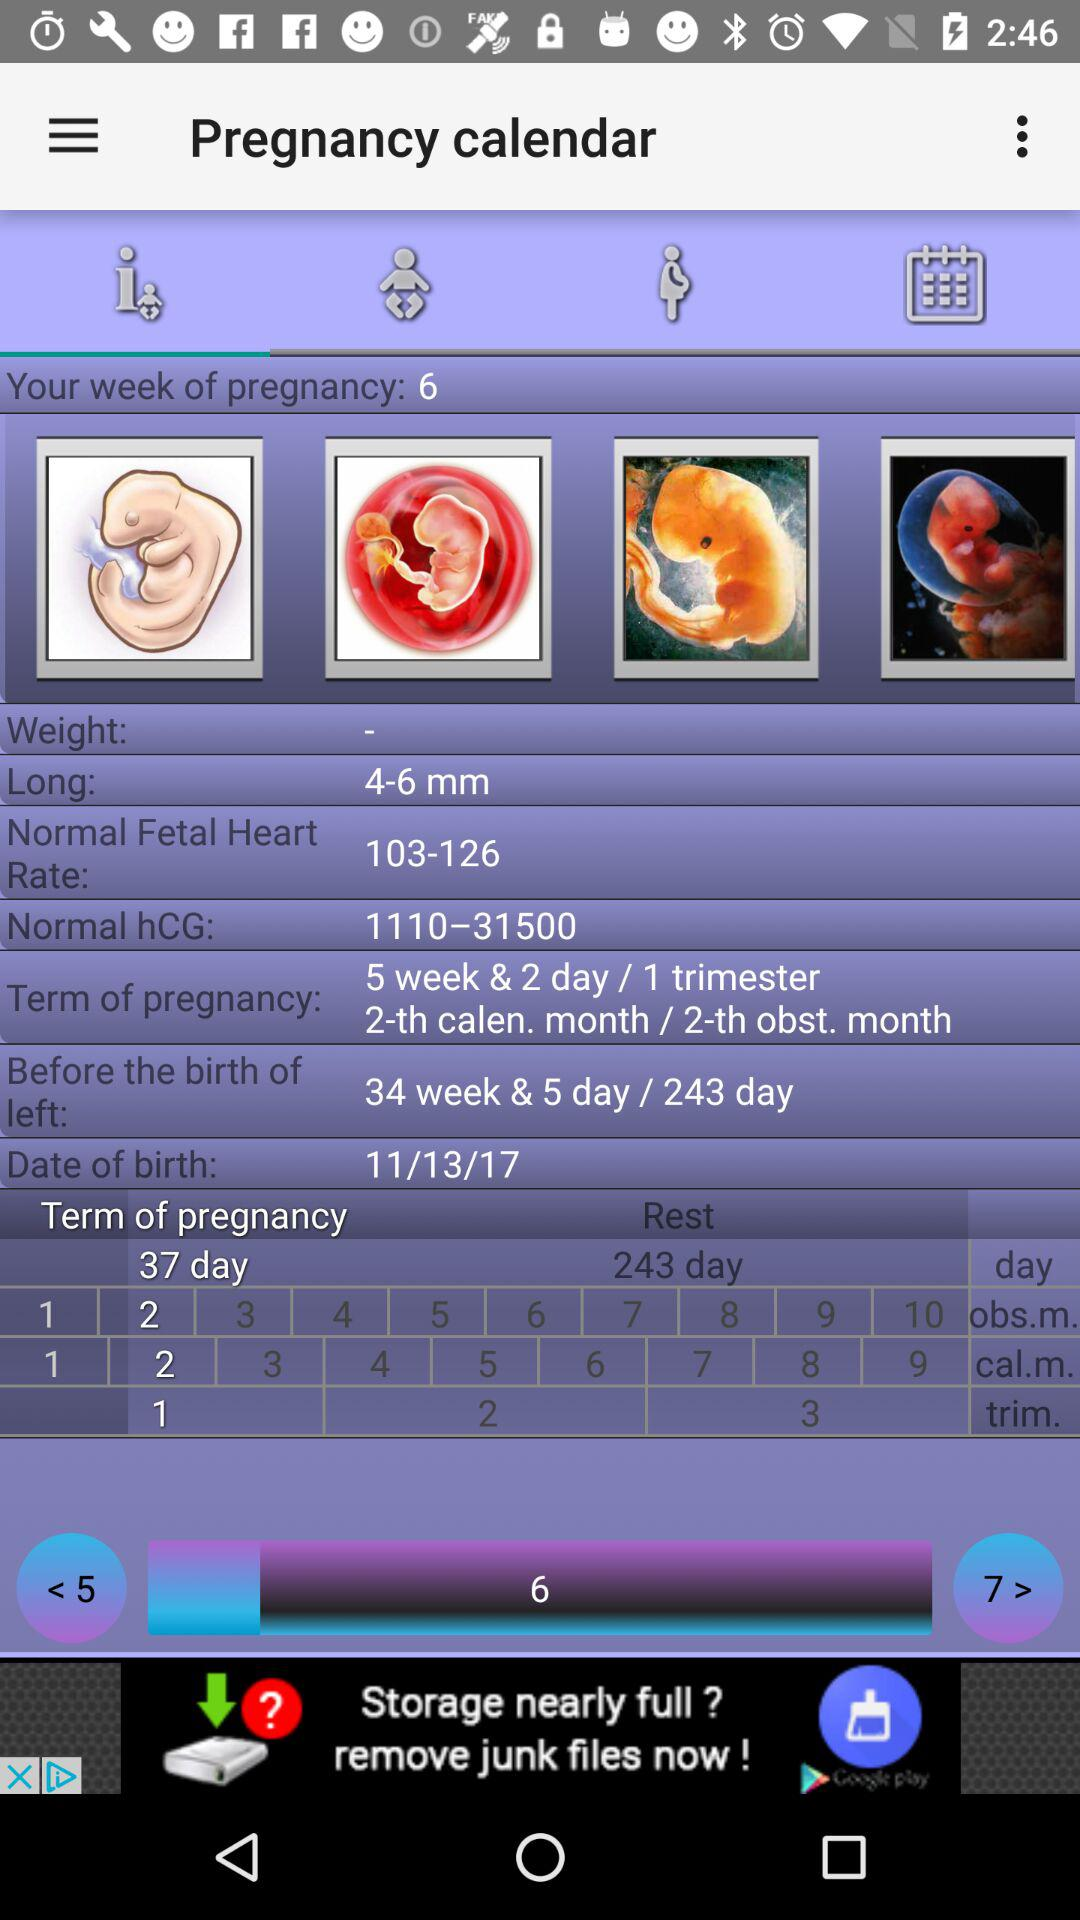What is the term of pregnancy? The term of pregnancy is 5 weeks and 2 days/1 trimester/2-th calender month/2-th obstetric month. 